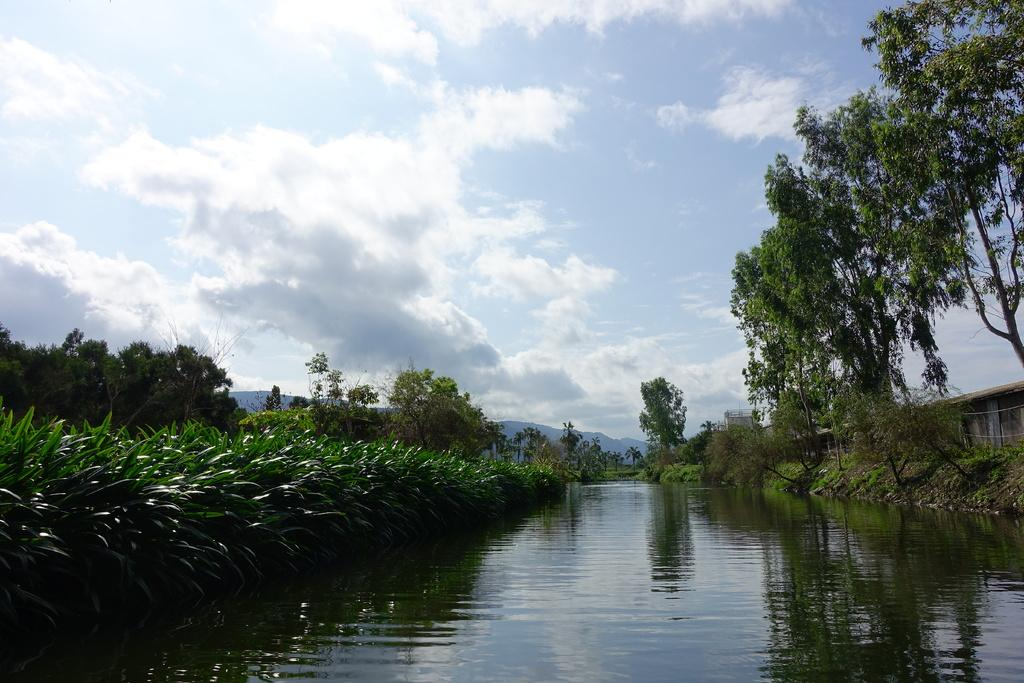What is the main element in the image? There is water in the image. What can be seen around the water? There are plants and trees around the water. What is visible in the background of the image? The sky is visible in the image. What can be observed in the sky? Clouds are present in the sky. What type of nose can be seen sticking out of the water in the image? There is no nose visible in the image; it features water with plants, trees, and a sky with clouds. 